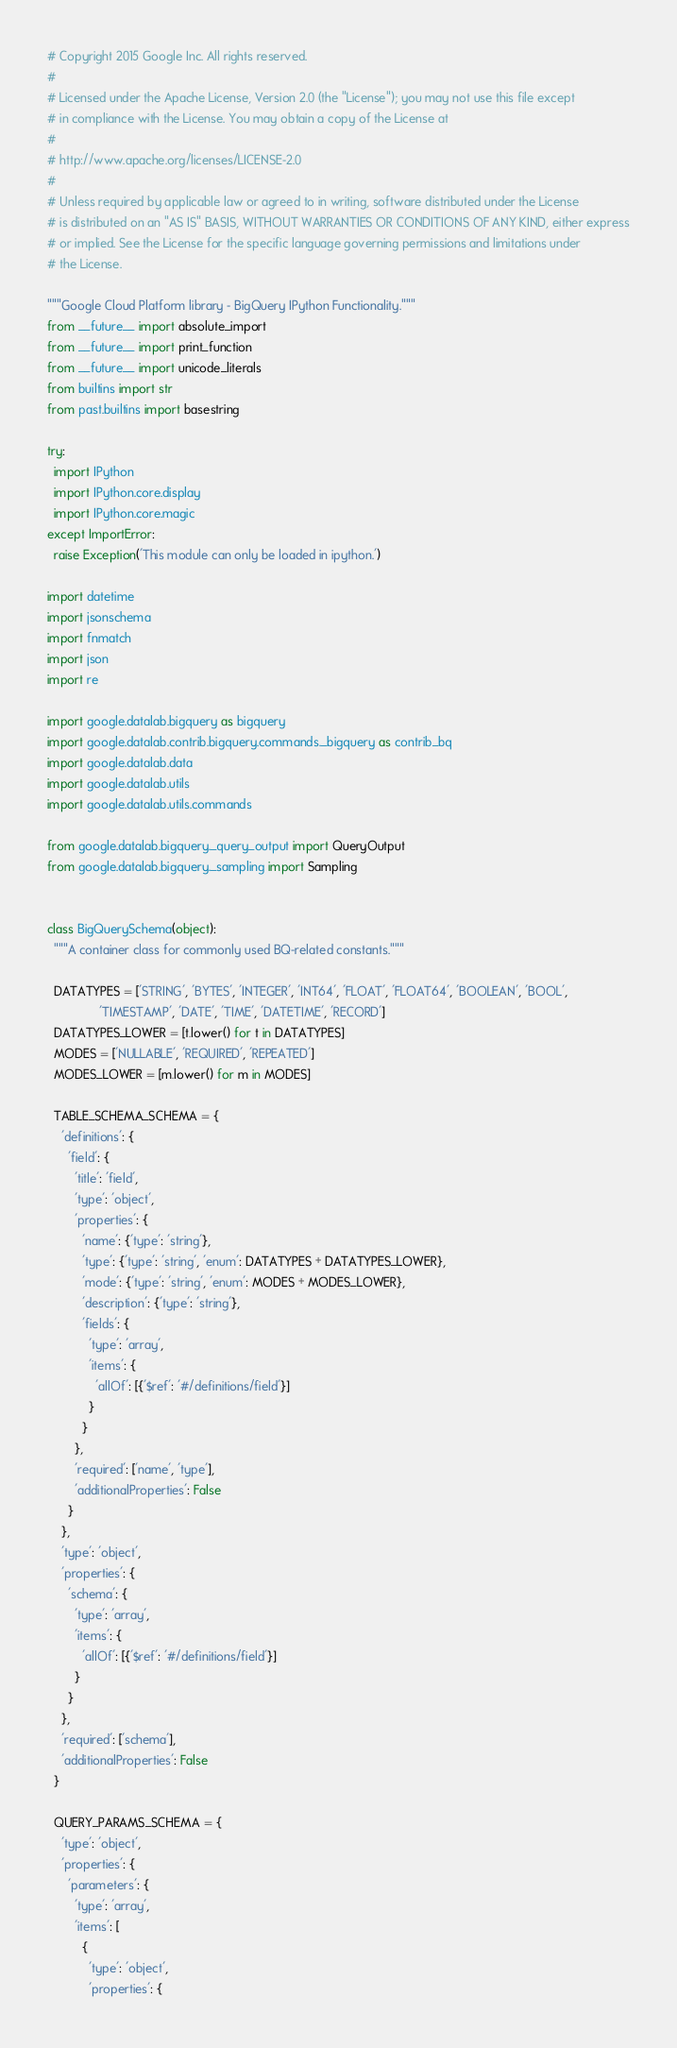Convert code to text. <code><loc_0><loc_0><loc_500><loc_500><_Python_># Copyright 2015 Google Inc. All rights reserved.
#
# Licensed under the Apache License, Version 2.0 (the "License"); you may not use this file except
# in compliance with the License. You may obtain a copy of the License at
#
# http://www.apache.org/licenses/LICENSE-2.0
#
# Unless required by applicable law or agreed to in writing, software distributed under the License
# is distributed on an "AS IS" BASIS, WITHOUT WARRANTIES OR CONDITIONS OF ANY KIND, either express
# or implied. See the License for the specific language governing permissions and limitations under
# the License.

"""Google Cloud Platform library - BigQuery IPython Functionality."""
from __future__ import absolute_import
from __future__ import print_function
from __future__ import unicode_literals
from builtins import str
from past.builtins import basestring

try:
  import IPython
  import IPython.core.display
  import IPython.core.magic
except ImportError:
  raise Exception('This module can only be loaded in ipython.')

import datetime
import jsonschema
import fnmatch
import json
import re

import google.datalab.bigquery as bigquery
import google.datalab.contrib.bigquery.commands._bigquery as contrib_bq
import google.datalab.data
import google.datalab.utils
import google.datalab.utils.commands

from google.datalab.bigquery._query_output import QueryOutput
from google.datalab.bigquery._sampling import Sampling


class BigQuerySchema(object):
  """A container class for commonly used BQ-related constants."""

  DATATYPES = ['STRING', 'BYTES', 'INTEGER', 'INT64', 'FLOAT', 'FLOAT64', 'BOOLEAN', 'BOOL',
               'TIMESTAMP', 'DATE', 'TIME', 'DATETIME', 'RECORD']
  DATATYPES_LOWER = [t.lower() for t in DATATYPES]
  MODES = ['NULLABLE', 'REQUIRED', 'REPEATED']
  MODES_LOWER = [m.lower() for m in MODES]

  TABLE_SCHEMA_SCHEMA = {
    'definitions': {
      'field': {
        'title': 'field',
        'type': 'object',
        'properties': {
          'name': {'type': 'string'},
          'type': {'type': 'string', 'enum': DATATYPES + DATATYPES_LOWER},
          'mode': {'type': 'string', 'enum': MODES + MODES_LOWER},
          'description': {'type': 'string'},
          'fields': {
            'type': 'array',
            'items': {
              'allOf': [{'$ref': '#/definitions/field'}]
            }
          }
        },
        'required': ['name', 'type'],
        'additionalProperties': False
      }
    },
    'type': 'object',
    'properties': {
      'schema': {
        'type': 'array',
        'items': {
          'allOf': [{'$ref': '#/definitions/field'}]
        }
      }
    },
    'required': ['schema'],
    'additionalProperties': False
  }

  QUERY_PARAMS_SCHEMA = {
    'type': 'object',
    'properties': {
      'parameters': {
        'type': 'array',
        'items': [
          {
            'type': 'object',
            'properties': {</code> 